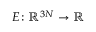<formula> <loc_0><loc_0><loc_500><loc_500>E \colon { \mathbb { R } } ^ { 3 N } \to { \mathbb { R } }</formula> 